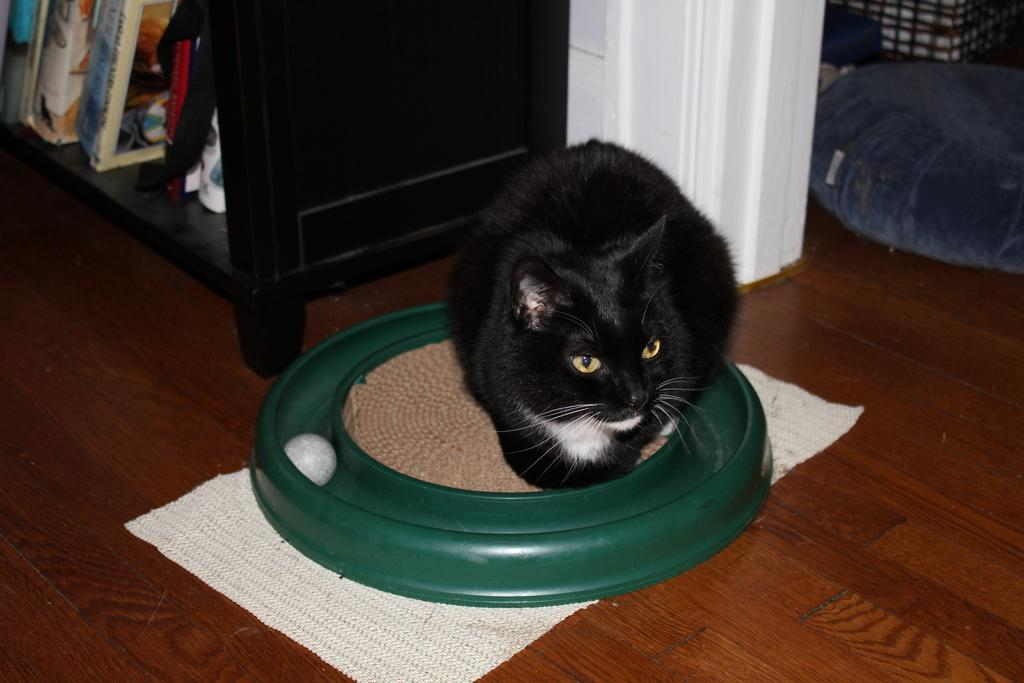What type of animal is in the image? There is a black color cat in the image. What is the cat sitting on? The cat is sitting on a green color dish. What is the surface beneath the dish? The dish is placed on wooden flooring tile. What else can be seen in the image made of wood? There is a wooden rack in the image. What is stored on the wooden rack? The wooden rack contains some books. What flavor of paper is the cat chewing on in the image? There is no paper present in the image, and the cat is not chewing on anything. 